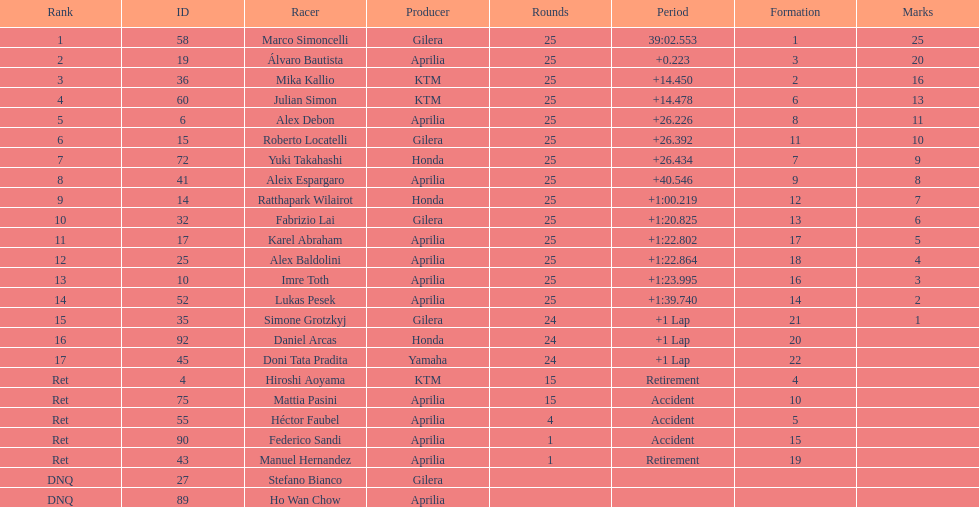How many riders manufacturer is honda? 3. 